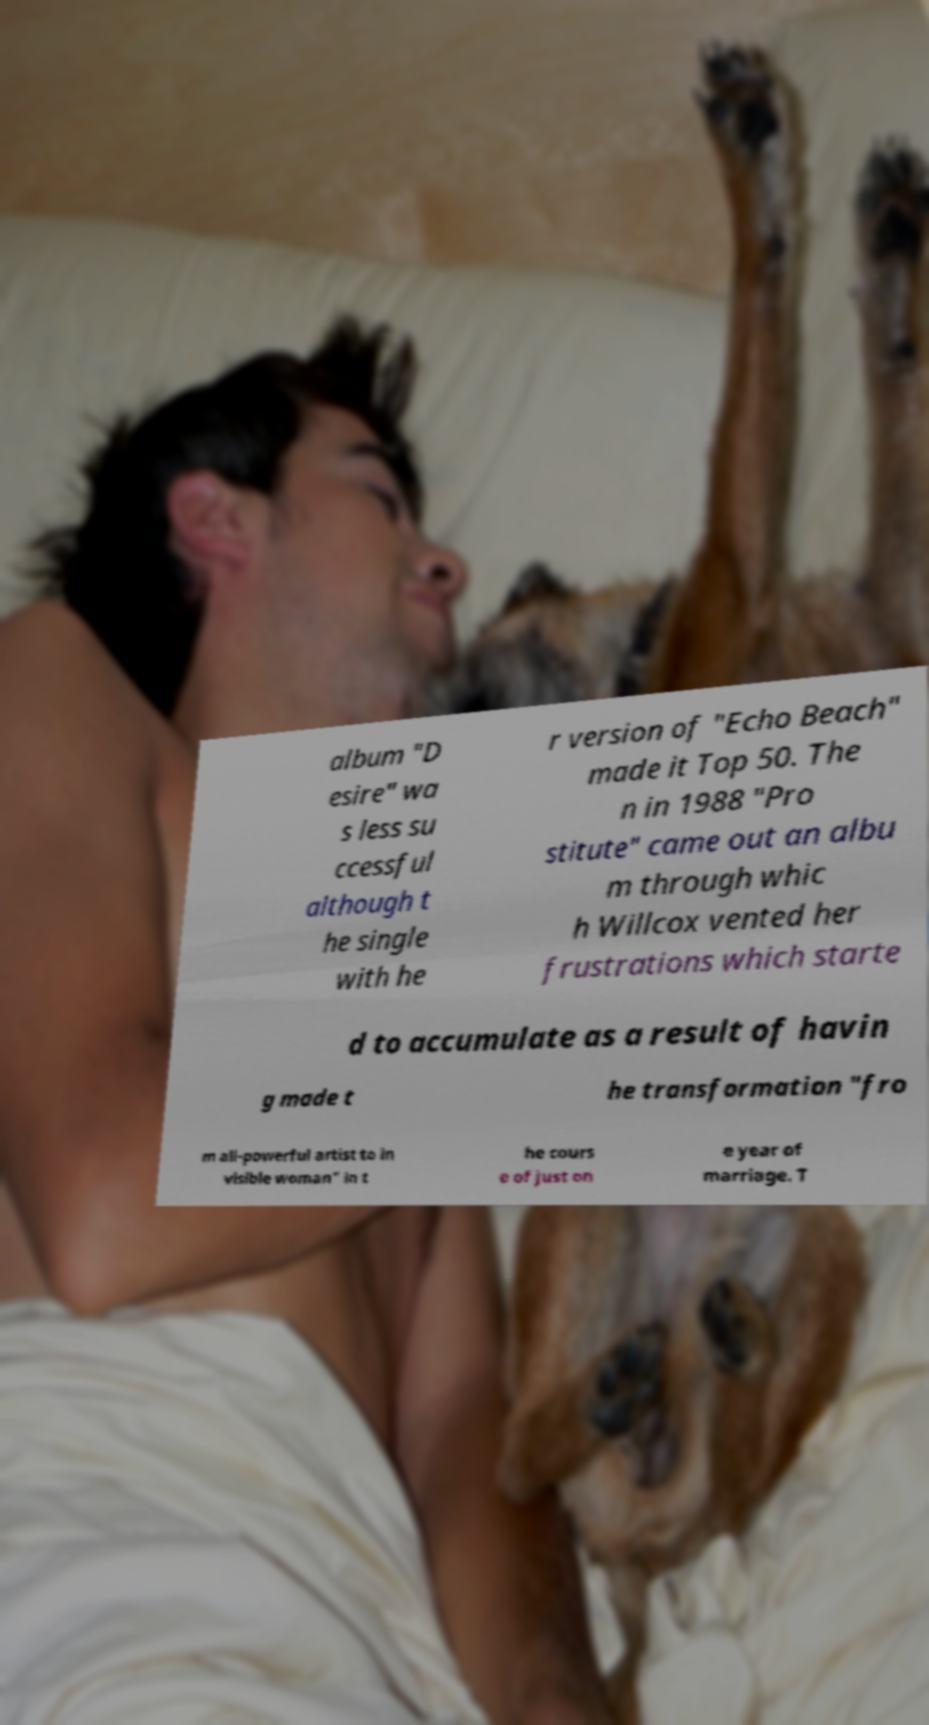Please identify and transcribe the text found in this image. album "D esire" wa s less su ccessful although t he single with he r version of "Echo Beach" made it Top 50. The n in 1988 "Pro stitute" came out an albu m through whic h Willcox vented her frustrations which starte d to accumulate as a result of havin g made t he transformation "fro m all-powerful artist to in visible woman" in t he cours e of just on e year of marriage. T 